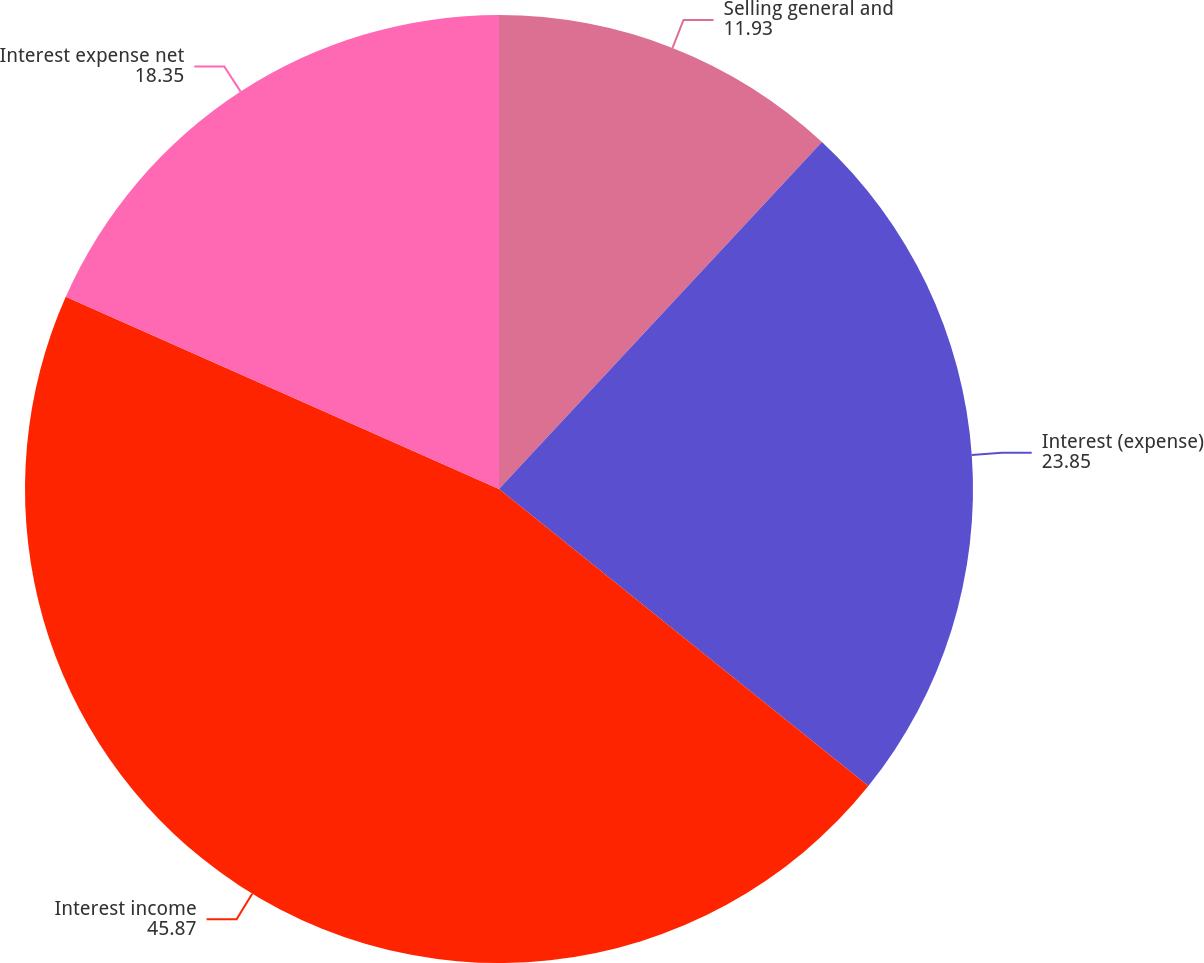Convert chart to OTSL. <chart><loc_0><loc_0><loc_500><loc_500><pie_chart><fcel>Selling general and<fcel>Interest (expense)<fcel>Interest income<fcel>Interest expense net<nl><fcel>11.93%<fcel>23.85%<fcel>45.87%<fcel>18.35%<nl></chart> 